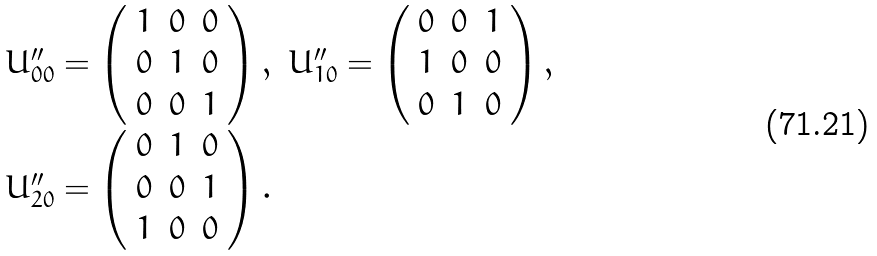Convert formula to latex. <formula><loc_0><loc_0><loc_500><loc_500>\begin{array} { l l } U ^ { \prime \prime } _ { 0 0 } = \left ( \begin{array} { c c c } 1 & 0 & 0 \\ 0 & 1 & 0 \\ 0 & 0 & 1 \end{array} \right ) , & U ^ { \prime \prime } _ { 1 0 } = \left ( \begin{array} { c c c } 0 & 0 & 1 \\ 1 & 0 & 0 \\ 0 & 1 & 0 \end{array} \right ) , \\ U ^ { \prime \prime } _ { 2 0 } = \left ( \begin{array} { c c c } 0 & 1 & 0 \\ 0 & 0 & 1 \\ 1 & 0 & 0 \end{array} \right ) . \end{array}</formula> 